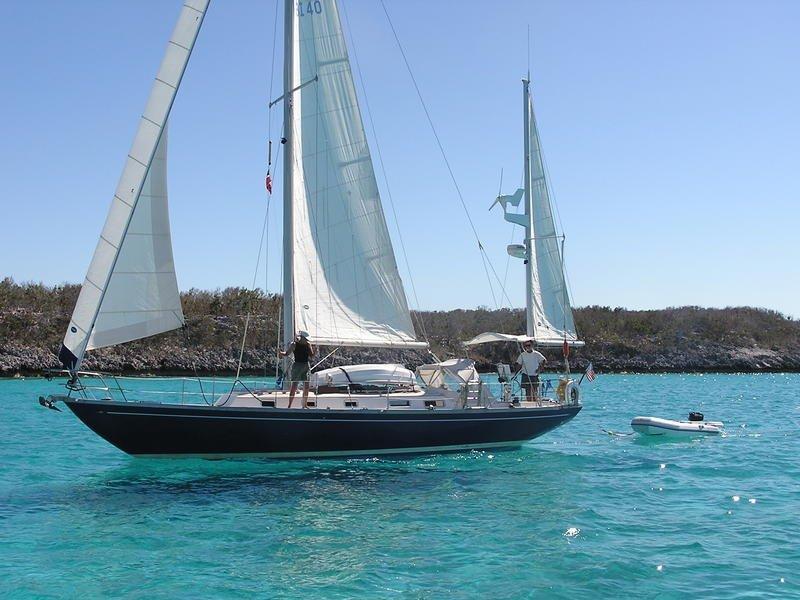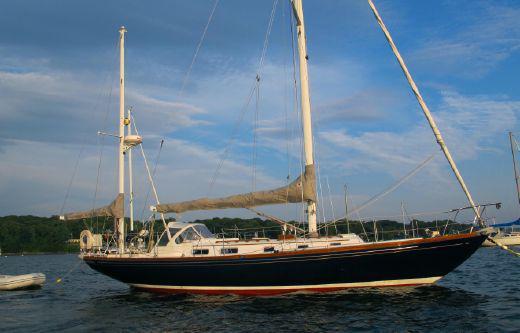The first image is the image on the left, the second image is the image on the right. For the images displayed, is the sentence "At least one boat has a black body." factually correct? Answer yes or no. Yes. The first image is the image on the left, the second image is the image on the right. Given the left and right images, does the statement "The boat on the right has a blue sail cover covering one of the sails." hold true? Answer yes or no. No. 